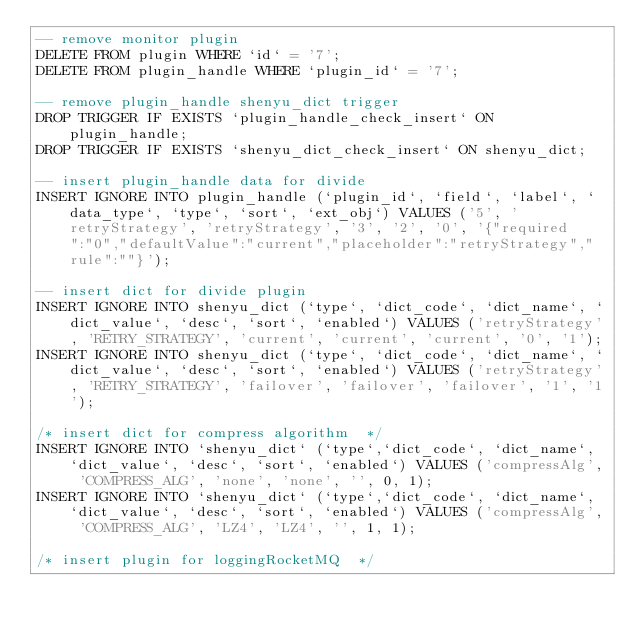<code> <loc_0><loc_0><loc_500><loc_500><_SQL_>-- remove monitor plugin
DELETE FROM plugin WHERE `id` = '7';
DELETE FROM plugin_handle WHERE `plugin_id` = '7';

-- remove plugin_handle shenyu_dict trigger
DROP TRIGGER IF EXISTS `plugin_handle_check_insert` ON plugin_handle;
DROP TRIGGER IF EXISTS `shenyu_dict_check_insert` ON shenyu_dict;

-- insert plugin_handle data for divide
INSERT IGNORE INTO plugin_handle (`plugin_id`, `field`, `label`, `data_type`, `type`, `sort`, `ext_obj`) VALUES ('5', 'retryStrategy', 'retryStrategy', '3', '2', '0', '{"required":"0","defaultValue":"current","placeholder":"retryStrategy","rule":""}');

-- insert dict for divide plugin
INSERT IGNORE INTO shenyu_dict (`type`, `dict_code`, `dict_name`, `dict_value`, `desc`, `sort`, `enabled`) VALUES ('retryStrategy', 'RETRY_STRATEGY', 'current', 'current', 'current', '0', '1');
INSERT IGNORE INTO shenyu_dict (`type`, `dict_code`, `dict_name`, `dict_value`, `desc`, `sort`, `enabled`) VALUES ('retryStrategy', 'RETRY_STRATEGY', 'failover', 'failover', 'failover', '1', '1');

/* insert dict for compress algorithm  */
INSERT IGNORE INTO `shenyu_dict` (`type`,`dict_code`, `dict_name`, `dict_value`, `desc`, `sort`, `enabled`) VALUES ('compressAlg', 'COMPRESS_ALG', 'none', 'none', '', 0, 1);
INSERT IGNORE INTO `shenyu_dict` (`type`,`dict_code`, `dict_name`, `dict_value`, `desc`, `sort`, `enabled`) VALUES ('compressAlg', 'COMPRESS_ALG', 'LZ4', 'LZ4', '', 1, 1);

/* insert plugin for loggingRocketMQ  */</code> 